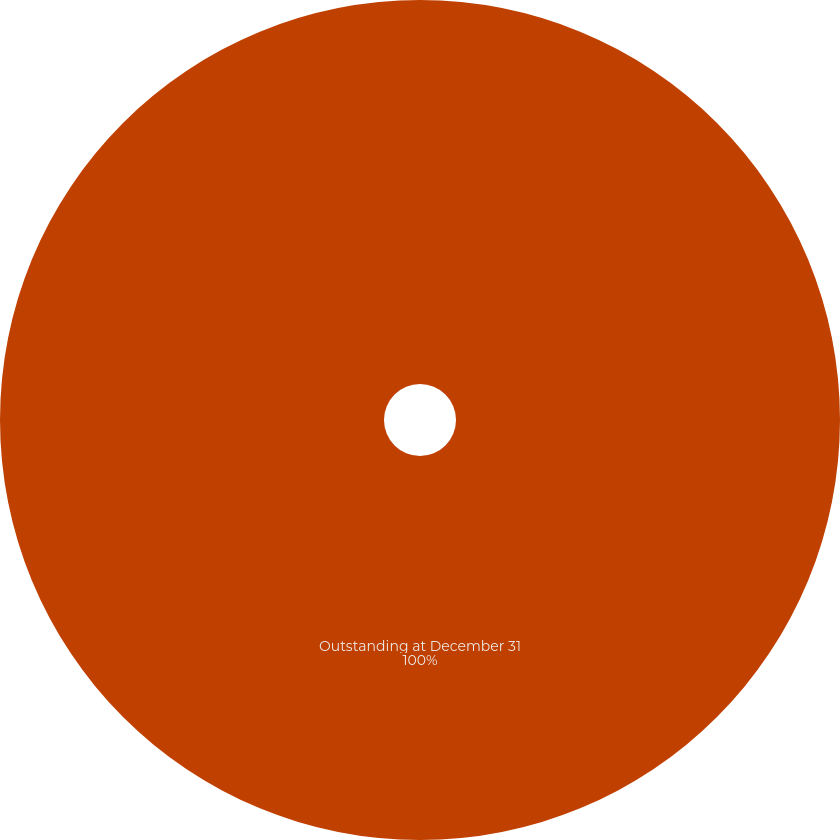Convert chart. <chart><loc_0><loc_0><loc_500><loc_500><pie_chart><fcel>Outstanding at December 31<nl><fcel>100.0%<nl></chart> 